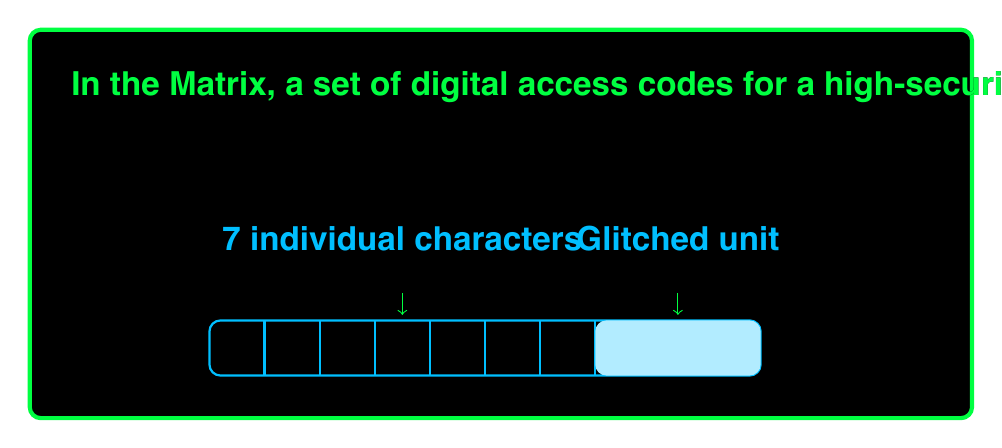Solve this math problem. Let's approach this step-by-step:

1) We start with 10 unique characters, but due to the glitch, 3 of these characters always appear together in the same order. This effectively reduces our problem to arranging 8 elements: 7 individual characters and 1 glitched unit.

2) The number of permutations for n distinct objects is given by n!. In this case, we have 8 distinct elements to arrange.

3) Therefore, the number of distinct permutations is:

   $$8! = 8 \times 7 \times 6 \times 5 \times 4 \times 3 \times 2 \times 1 = 40,320$$

4) We can verify this using the permutation formula:

   $$P(n,r) = \frac{n!}{(n-r)!}$$

   Where n is the total number of elements and r is the number of elements being arranged.

   $$P(8,8) = \frac{8!}{(8-8)!} = \frac{8!}{0!} = 8! = 40,320$$

5) It's worth noting that while we have 40,320 permutations of the access code as a whole, the 3 characters within the glitched unit maintain their fixed order in all of these permutations.
Answer: 40,320 